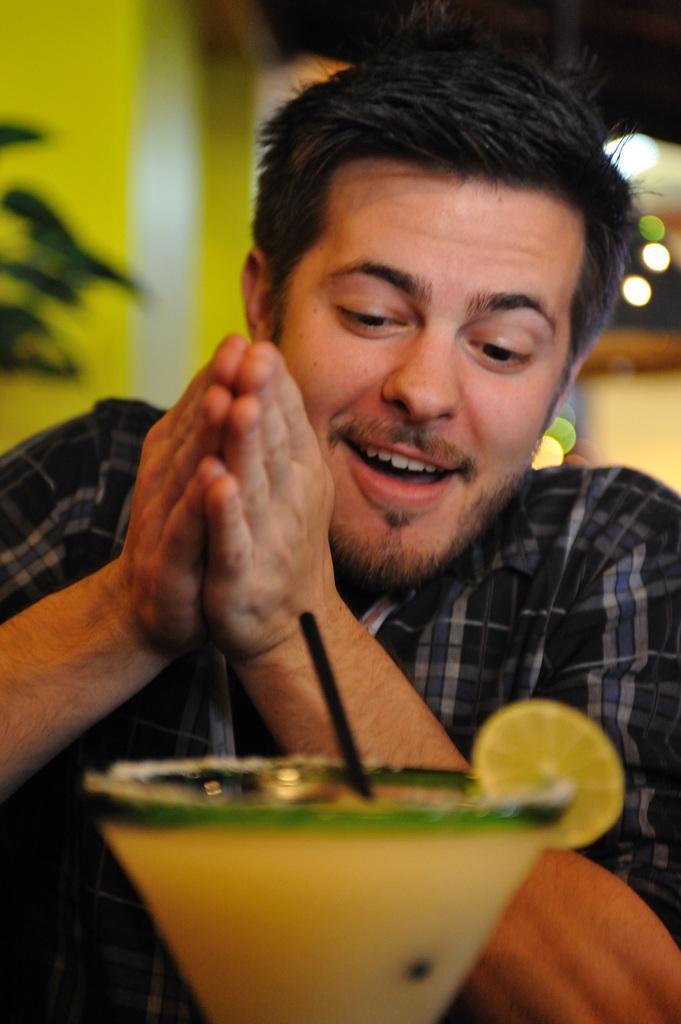Could you give a brief overview of what you see in this image? In this image there is a person, there is juice in the glass, there is a wall, there is a straw in the glass. 